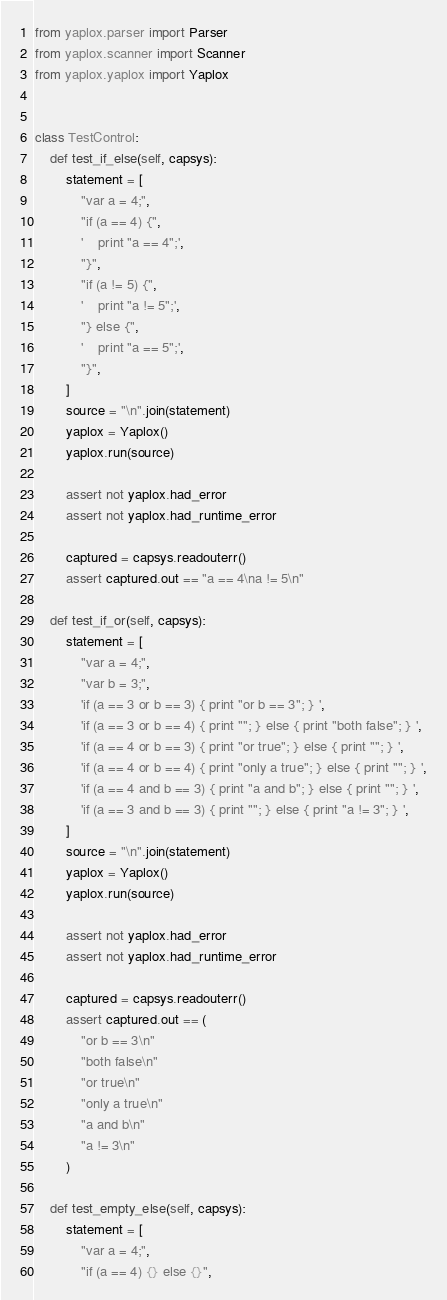<code> <loc_0><loc_0><loc_500><loc_500><_Python_>from yaplox.parser import Parser
from yaplox.scanner import Scanner
from yaplox.yaplox import Yaplox


class TestControl:
    def test_if_else(self, capsys):
        statement = [
            "var a = 4;",
            "if (a == 4) {",
            '    print "a == 4";',
            "}",
            "if (a != 5) {",
            '    print "a != 5";',
            "} else {",
            '    print "a == 5";',
            "}",
        ]
        source = "\n".join(statement)
        yaplox = Yaplox()
        yaplox.run(source)

        assert not yaplox.had_error
        assert not yaplox.had_runtime_error

        captured = capsys.readouterr()
        assert captured.out == "a == 4\na != 5\n"

    def test_if_or(self, capsys):
        statement = [
            "var a = 4;",
            "var b = 3;",
            'if (a == 3 or b == 3) { print "or b == 3"; } ',
            'if (a == 3 or b == 4) { print ""; } else { print "both false"; } ',
            'if (a == 4 or b == 3) { print "or true"; } else { print ""; } ',
            'if (a == 4 or b == 4) { print "only a true"; } else { print ""; } ',
            'if (a == 4 and b == 3) { print "a and b"; } else { print ""; } ',
            'if (a == 3 and b == 3) { print ""; } else { print "a != 3"; } ',
        ]
        source = "\n".join(statement)
        yaplox = Yaplox()
        yaplox.run(source)

        assert not yaplox.had_error
        assert not yaplox.had_runtime_error

        captured = capsys.readouterr()
        assert captured.out == (
            "or b == 3\n"
            "both false\n"
            "or true\n"
            "only a true\n"
            "a and b\n"
            "a != 3\n"
        )

    def test_empty_else(self, capsys):
        statement = [
            "var a = 4;",
            "if (a == 4) {} else {}",</code> 